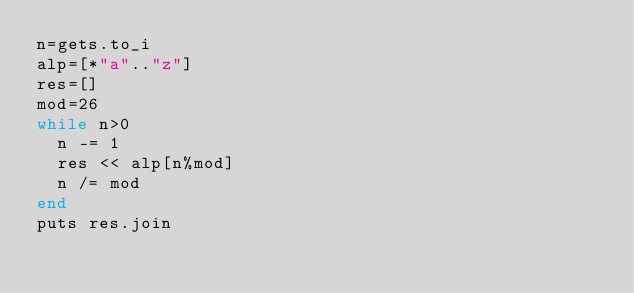Convert code to text. <code><loc_0><loc_0><loc_500><loc_500><_Ruby_>n=gets.to_i
alp=[*"a".."z"]
res=[]
mod=26
while n>0
  n -= 1
  res << alp[n%mod]
  n /= mod 
end
puts res.join</code> 